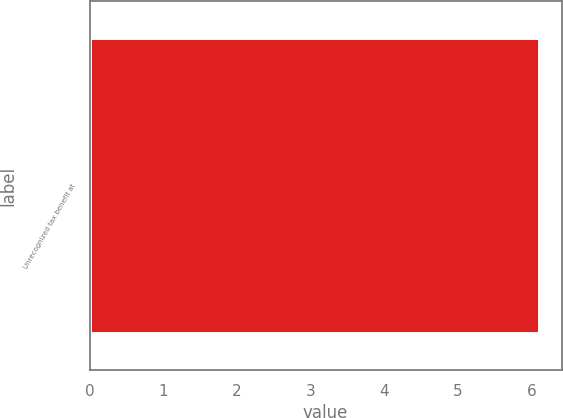Convert chart to OTSL. <chart><loc_0><loc_0><loc_500><loc_500><bar_chart><fcel>Unrecognized tax benefit at<nl><fcel>6.1<nl></chart> 